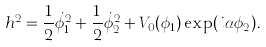<formula> <loc_0><loc_0><loc_500><loc_500>h ^ { 2 } = \frac { 1 } { 2 } \dot { \phi } _ { 1 } ^ { 2 } + \frac { 1 } { 2 } \dot { \phi } _ { 2 } ^ { 2 } + V _ { 0 } ( \phi _ { 1 } ) \exp ( i \alpha \phi _ { 2 } ) .</formula> 